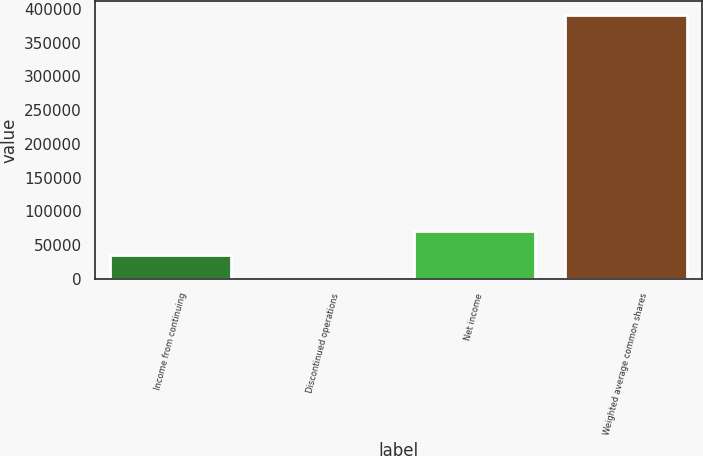Convert chart. <chart><loc_0><loc_0><loc_500><loc_500><bar_chart><fcel>Income from continuing<fcel>Discontinued operations<fcel>Net income<fcel>Weighted average common shares<nl><fcel>35640.8<fcel>45<fcel>71236.6<fcel>391599<nl></chart> 